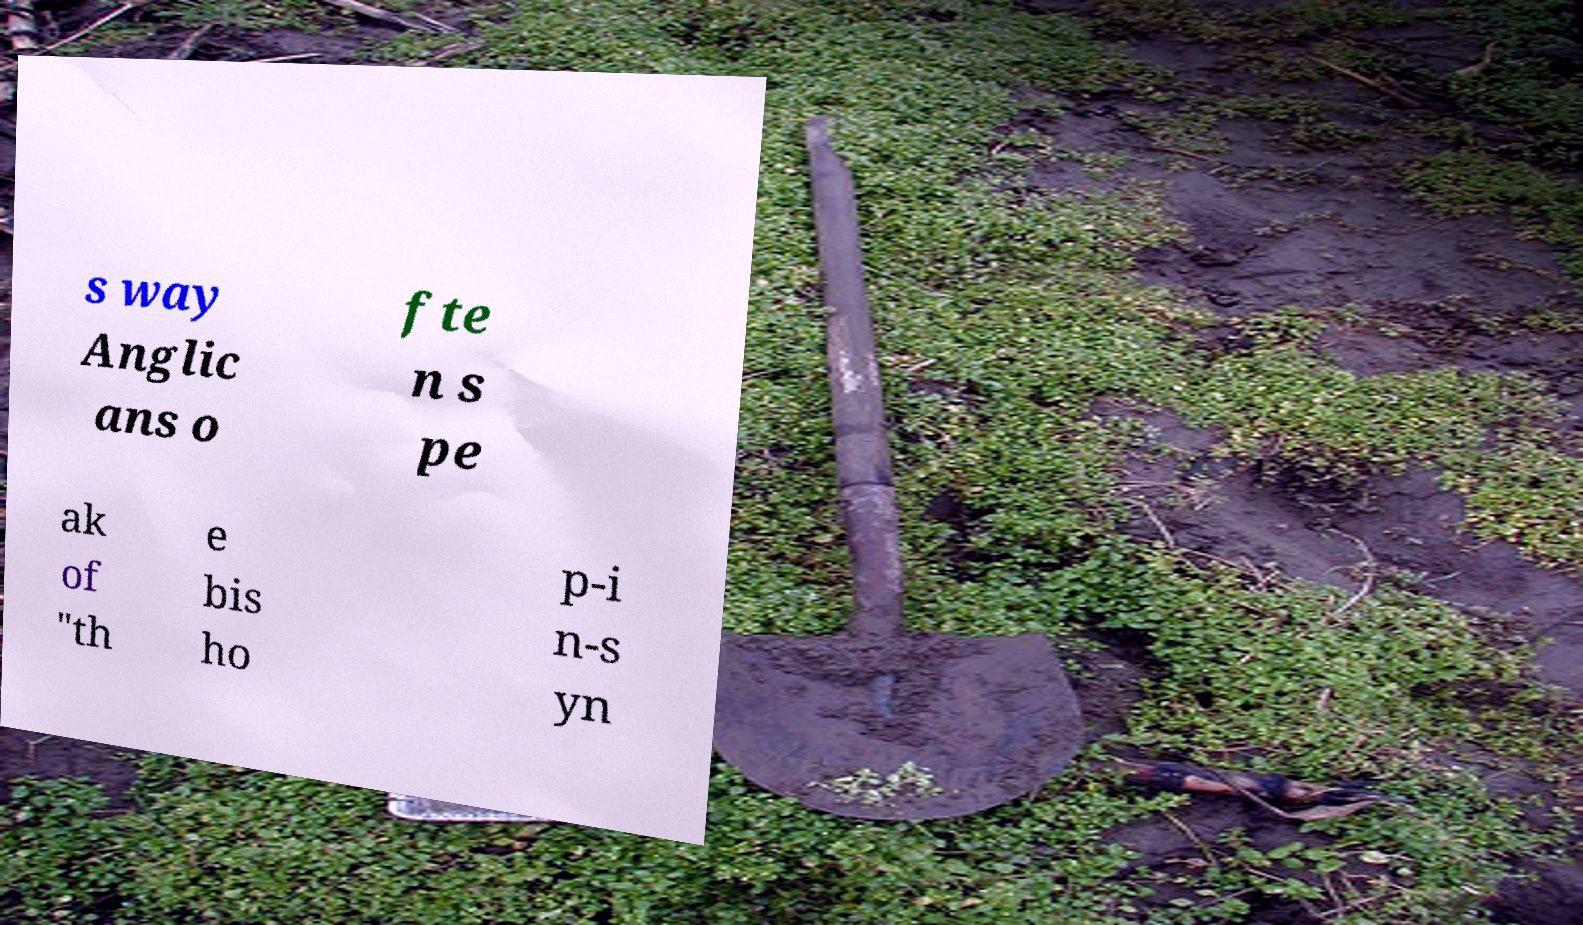What messages or text are displayed in this image? I need them in a readable, typed format. s way Anglic ans o fte n s pe ak of "th e bis ho p-i n-s yn 